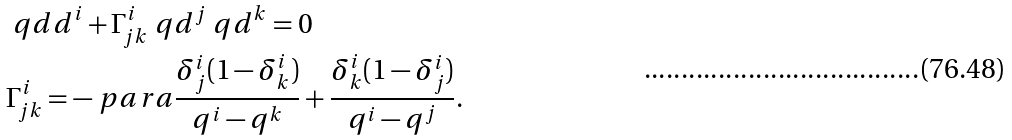Convert formula to latex. <formula><loc_0><loc_0><loc_500><loc_500>& \ q d d ^ { i } + \Gamma _ { j k } ^ { i } \ q d ^ { j } \ q d ^ { k } = 0 \\ & \Gamma _ { j k } ^ { i } = - \ p a r a { \frac { \delta _ { j } ^ { i } ( 1 - \delta _ { k } ^ { i } ) } { q ^ { i } - q ^ { k } } + \frac { \delta _ { k } ^ { i } ( 1 - \delta _ { j } ^ { i } ) } { q ^ { i } - q ^ { j } } } .</formula> 